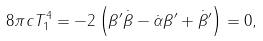Convert formula to latex. <formula><loc_0><loc_0><loc_500><loc_500>8 \pi c T ^ { 4 } _ { 1 } = - 2 \left ( \beta ^ { \prime } \dot { \beta } - \dot { \alpha } \beta ^ { \prime } + \dot { \beta } ^ { \prime } \right ) = 0 ,</formula> 